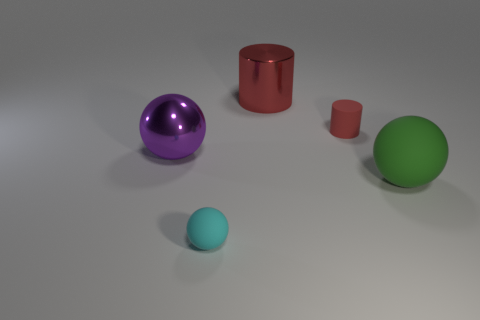Add 1 large green matte things. How many objects exist? 6 Subtract all balls. How many objects are left? 2 Add 3 large green matte spheres. How many large green matte spheres are left? 4 Add 4 big red spheres. How many big red spheres exist? 4 Subtract 0 yellow blocks. How many objects are left? 5 Subtract all small purple spheres. Subtract all large purple balls. How many objects are left? 4 